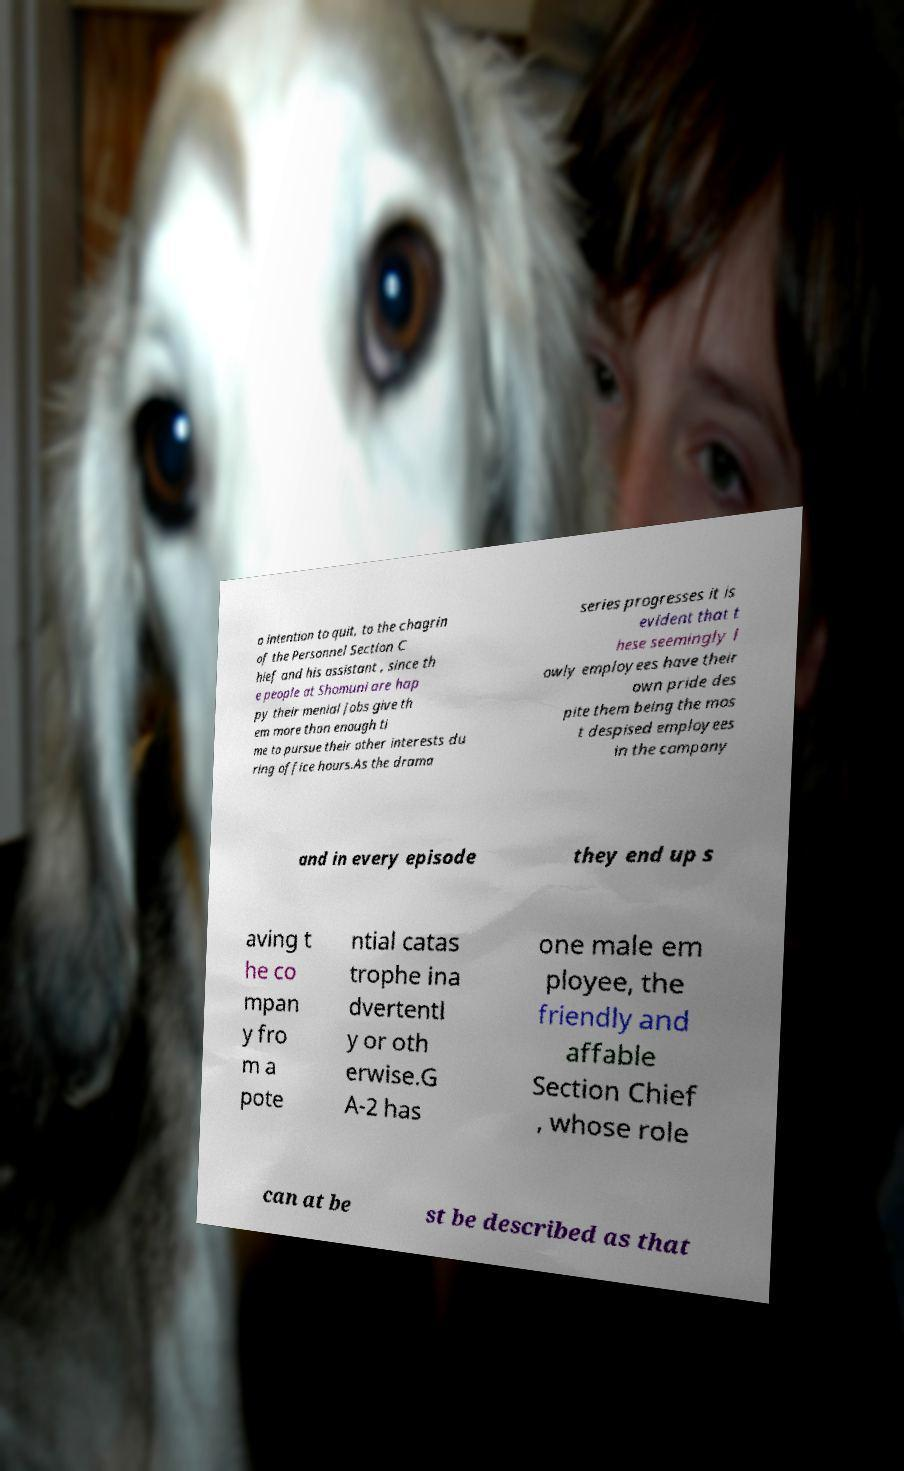There's text embedded in this image that I need extracted. Can you transcribe it verbatim? o intention to quit, to the chagrin of the Personnel Section C hief and his assistant , since th e people at Shomuni are hap py their menial jobs give th em more than enough ti me to pursue their other interests du ring office hours.As the drama series progresses it is evident that t hese seemingly l owly employees have their own pride des pite them being the mos t despised employees in the company and in every episode they end up s aving t he co mpan y fro m a pote ntial catas trophe ina dvertentl y or oth erwise.G A-2 has one male em ployee, the friendly and affable Section Chief , whose role can at be st be described as that 